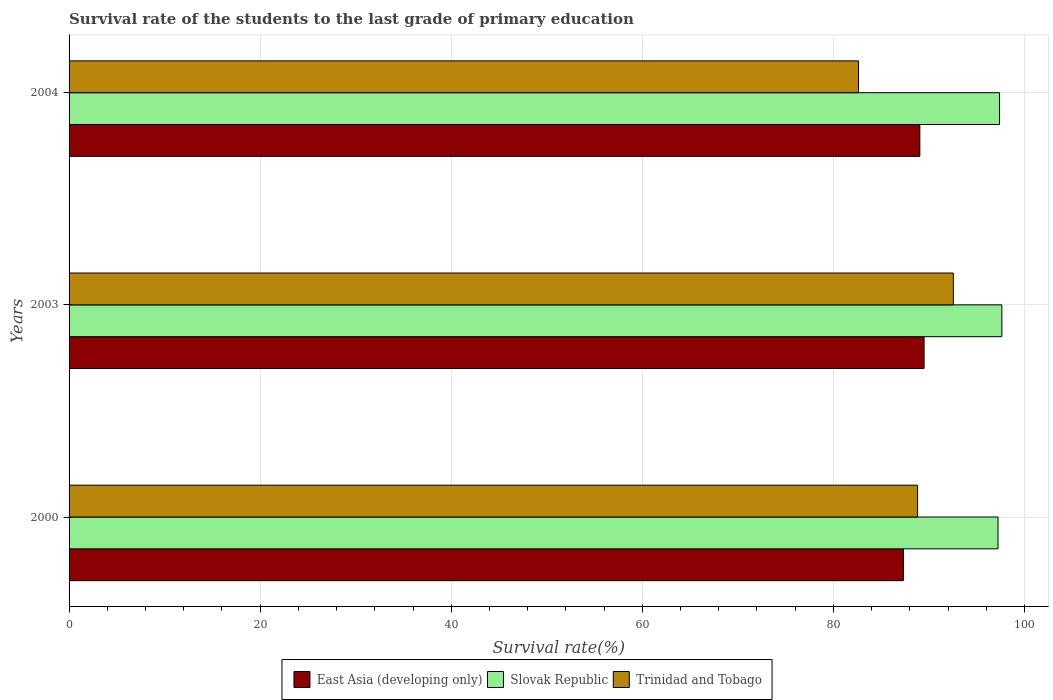How many different coloured bars are there?
Make the answer very short. 3. How many groups of bars are there?
Make the answer very short. 3. Are the number of bars on each tick of the Y-axis equal?
Ensure brevity in your answer.  Yes. How many bars are there on the 2nd tick from the top?
Make the answer very short. 3. How many bars are there on the 3rd tick from the bottom?
Your answer should be compact. 3. In how many cases, is the number of bars for a given year not equal to the number of legend labels?
Provide a short and direct response. 0. What is the survival rate of the students in Trinidad and Tobago in 2004?
Provide a succinct answer. 82.63. Across all years, what is the maximum survival rate of the students in Slovak Republic?
Your answer should be very brief. 97.64. Across all years, what is the minimum survival rate of the students in Slovak Republic?
Make the answer very short. 97.23. What is the total survival rate of the students in East Asia (developing only) in the graph?
Your answer should be very brief. 265.88. What is the difference between the survival rate of the students in Slovak Republic in 2000 and that in 2004?
Your response must be concise. -0.16. What is the difference between the survival rate of the students in Slovak Republic in 2000 and the survival rate of the students in East Asia (developing only) in 2003?
Your answer should be very brief. 7.74. What is the average survival rate of the students in Trinidad and Tobago per year?
Make the answer very short. 88. In the year 2003, what is the difference between the survival rate of the students in Trinidad and Tobago and survival rate of the students in East Asia (developing only)?
Provide a short and direct response. 3.06. In how many years, is the survival rate of the students in East Asia (developing only) greater than 68 %?
Ensure brevity in your answer.  3. What is the ratio of the survival rate of the students in East Asia (developing only) in 2000 to that in 2003?
Offer a terse response. 0.98. Is the survival rate of the students in Slovak Republic in 2003 less than that in 2004?
Your response must be concise. No. Is the difference between the survival rate of the students in Trinidad and Tobago in 2000 and 2004 greater than the difference between the survival rate of the students in East Asia (developing only) in 2000 and 2004?
Make the answer very short. Yes. What is the difference between the highest and the second highest survival rate of the students in East Asia (developing only)?
Your answer should be very brief. 0.44. What is the difference between the highest and the lowest survival rate of the students in Trinidad and Tobago?
Provide a succinct answer. 9.92. What does the 3rd bar from the top in 2000 represents?
Offer a terse response. East Asia (developing only). What does the 1st bar from the bottom in 2003 represents?
Keep it short and to the point. East Asia (developing only). Is it the case that in every year, the sum of the survival rate of the students in Slovak Republic and survival rate of the students in Trinidad and Tobago is greater than the survival rate of the students in East Asia (developing only)?
Your response must be concise. Yes. How many bars are there?
Your answer should be very brief. 9. How many years are there in the graph?
Give a very brief answer. 3. Are the values on the major ticks of X-axis written in scientific E-notation?
Your answer should be compact. No. Does the graph contain grids?
Give a very brief answer. Yes. Where does the legend appear in the graph?
Ensure brevity in your answer.  Bottom center. What is the title of the graph?
Ensure brevity in your answer.  Survival rate of the students to the last grade of primary education. What is the label or title of the X-axis?
Give a very brief answer. Survival rate(%). What is the label or title of the Y-axis?
Keep it short and to the point. Years. What is the Survival rate(%) of East Asia (developing only) in 2000?
Your answer should be compact. 87.33. What is the Survival rate(%) in Slovak Republic in 2000?
Your answer should be compact. 97.23. What is the Survival rate(%) of Trinidad and Tobago in 2000?
Your answer should be compact. 88.82. What is the Survival rate(%) of East Asia (developing only) in 2003?
Offer a very short reply. 89.5. What is the Survival rate(%) of Slovak Republic in 2003?
Ensure brevity in your answer.  97.64. What is the Survival rate(%) of Trinidad and Tobago in 2003?
Give a very brief answer. 92.56. What is the Survival rate(%) in East Asia (developing only) in 2004?
Ensure brevity in your answer.  89.05. What is the Survival rate(%) of Slovak Republic in 2004?
Provide a succinct answer. 97.4. What is the Survival rate(%) in Trinidad and Tobago in 2004?
Give a very brief answer. 82.63. Across all years, what is the maximum Survival rate(%) of East Asia (developing only)?
Make the answer very short. 89.5. Across all years, what is the maximum Survival rate(%) in Slovak Republic?
Offer a terse response. 97.64. Across all years, what is the maximum Survival rate(%) in Trinidad and Tobago?
Offer a terse response. 92.56. Across all years, what is the minimum Survival rate(%) of East Asia (developing only)?
Offer a very short reply. 87.33. Across all years, what is the minimum Survival rate(%) of Slovak Republic?
Give a very brief answer. 97.23. Across all years, what is the minimum Survival rate(%) of Trinidad and Tobago?
Make the answer very short. 82.63. What is the total Survival rate(%) in East Asia (developing only) in the graph?
Your answer should be compact. 265.88. What is the total Survival rate(%) of Slovak Republic in the graph?
Offer a terse response. 292.26. What is the total Survival rate(%) of Trinidad and Tobago in the graph?
Ensure brevity in your answer.  264.01. What is the difference between the Survival rate(%) of East Asia (developing only) in 2000 and that in 2003?
Offer a very short reply. -2.17. What is the difference between the Survival rate(%) in Slovak Republic in 2000 and that in 2003?
Ensure brevity in your answer.  -0.4. What is the difference between the Survival rate(%) in Trinidad and Tobago in 2000 and that in 2003?
Your response must be concise. -3.74. What is the difference between the Survival rate(%) in East Asia (developing only) in 2000 and that in 2004?
Ensure brevity in your answer.  -1.72. What is the difference between the Survival rate(%) in Slovak Republic in 2000 and that in 2004?
Offer a terse response. -0.16. What is the difference between the Survival rate(%) in Trinidad and Tobago in 2000 and that in 2004?
Offer a very short reply. 6.18. What is the difference between the Survival rate(%) in East Asia (developing only) in 2003 and that in 2004?
Make the answer very short. 0.44. What is the difference between the Survival rate(%) in Slovak Republic in 2003 and that in 2004?
Your response must be concise. 0.24. What is the difference between the Survival rate(%) in Trinidad and Tobago in 2003 and that in 2004?
Your response must be concise. 9.92. What is the difference between the Survival rate(%) in East Asia (developing only) in 2000 and the Survival rate(%) in Slovak Republic in 2003?
Provide a succinct answer. -10.31. What is the difference between the Survival rate(%) in East Asia (developing only) in 2000 and the Survival rate(%) in Trinidad and Tobago in 2003?
Offer a very short reply. -5.23. What is the difference between the Survival rate(%) in Slovak Republic in 2000 and the Survival rate(%) in Trinidad and Tobago in 2003?
Your answer should be compact. 4.68. What is the difference between the Survival rate(%) of East Asia (developing only) in 2000 and the Survival rate(%) of Slovak Republic in 2004?
Provide a short and direct response. -10.07. What is the difference between the Survival rate(%) in East Asia (developing only) in 2000 and the Survival rate(%) in Trinidad and Tobago in 2004?
Your answer should be compact. 4.7. What is the difference between the Survival rate(%) of Slovak Republic in 2000 and the Survival rate(%) of Trinidad and Tobago in 2004?
Offer a very short reply. 14.6. What is the difference between the Survival rate(%) of East Asia (developing only) in 2003 and the Survival rate(%) of Slovak Republic in 2004?
Ensure brevity in your answer.  -7.9. What is the difference between the Survival rate(%) in East Asia (developing only) in 2003 and the Survival rate(%) in Trinidad and Tobago in 2004?
Give a very brief answer. 6.86. What is the difference between the Survival rate(%) in Slovak Republic in 2003 and the Survival rate(%) in Trinidad and Tobago in 2004?
Your answer should be compact. 15. What is the average Survival rate(%) in East Asia (developing only) per year?
Your answer should be very brief. 88.63. What is the average Survival rate(%) in Slovak Republic per year?
Ensure brevity in your answer.  97.42. What is the average Survival rate(%) of Trinidad and Tobago per year?
Your answer should be compact. 88. In the year 2000, what is the difference between the Survival rate(%) of East Asia (developing only) and Survival rate(%) of Slovak Republic?
Offer a terse response. -9.9. In the year 2000, what is the difference between the Survival rate(%) in East Asia (developing only) and Survival rate(%) in Trinidad and Tobago?
Offer a terse response. -1.49. In the year 2000, what is the difference between the Survival rate(%) of Slovak Republic and Survival rate(%) of Trinidad and Tobago?
Give a very brief answer. 8.42. In the year 2003, what is the difference between the Survival rate(%) in East Asia (developing only) and Survival rate(%) in Slovak Republic?
Your answer should be very brief. -8.14. In the year 2003, what is the difference between the Survival rate(%) in East Asia (developing only) and Survival rate(%) in Trinidad and Tobago?
Ensure brevity in your answer.  -3.06. In the year 2003, what is the difference between the Survival rate(%) in Slovak Republic and Survival rate(%) in Trinidad and Tobago?
Keep it short and to the point. 5.08. In the year 2004, what is the difference between the Survival rate(%) in East Asia (developing only) and Survival rate(%) in Slovak Republic?
Give a very brief answer. -8.34. In the year 2004, what is the difference between the Survival rate(%) of East Asia (developing only) and Survival rate(%) of Trinidad and Tobago?
Keep it short and to the point. 6.42. In the year 2004, what is the difference between the Survival rate(%) in Slovak Republic and Survival rate(%) in Trinidad and Tobago?
Your answer should be very brief. 14.76. What is the ratio of the Survival rate(%) in East Asia (developing only) in 2000 to that in 2003?
Your answer should be very brief. 0.98. What is the ratio of the Survival rate(%) in Slovak Republic in 2000 to that in 2003?
Keep it short and to the point. 1. What is the ratio of the Survival rate(%) of Trinidad and Tobago in 2000 to that in 2003?
Give a very brief answer. 0.96. What is the ratio of the Survival rate(%) of East Asia (developing only) in 2000 to that in 2004?
Provide a succinct answer. 0.98. What is the ratio of the Survival rate(%) in Trinidad and Tobago in 2000 to that in 2004?
Offer a terse response. 1.07. What is the ratio of the Survival rate(%) of East Asia (developing only) in 2003 to that in 2004?
Give a very brief answer. 1. What is the ratio of the Survival rate(%) in Trinidad and Tobago in 2003 to that in 2004?
Your answer should be very brief. 1.12. What is the difference between the highest and the second highest Survival rate(%) in East Asia (developing only)?
Provide a succinct answer. 0.44. What is the difference between the highest and the second highest Survival rate(%) of Slovak Republic?
Offer a very short reply. 0.24. What is the difference between the highest and the second highest Survival rate(%) in Trinidad and Tobago?
Offer a very short reply. 3.74. What is the difference between the highest and the lowest Survival rate(%) in East Asia (developing only)?
Keep it short and to the point. 2.17. What is the difference between the highest and the lowest Survival rate(%) of Slovak Republic?
Provide a short and direct response. 0.4. What is the difference between the highest and the lowest Survival rate(%) in Trinidad and Tobago?
Your answer should be very brief. 9.92. 